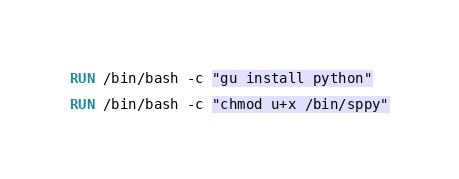<code> <loc_0><loc_0><loc_500><loc_500><_Dockerfile_>
RUN /bin/bash -c "gu install python"

RUN /bin/bash -c "chmod u+x /bin/sppy"
</code> 